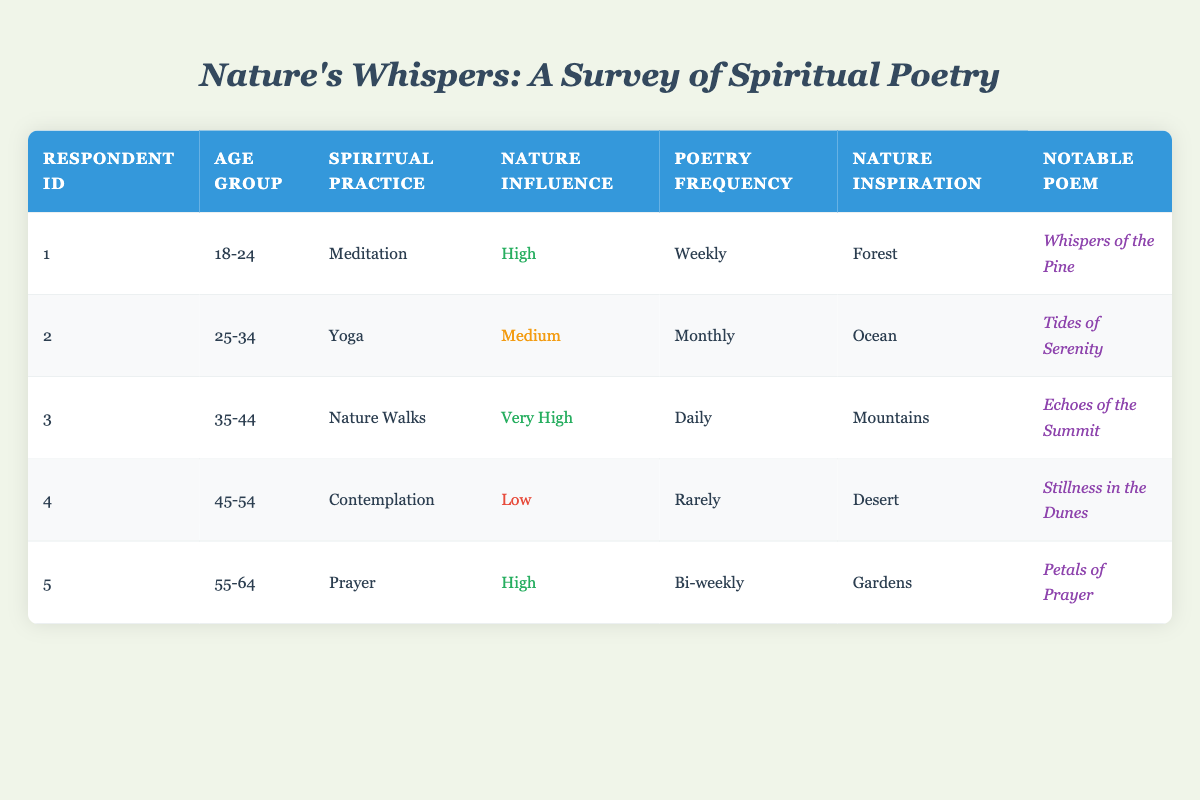What is the favorite nature inspiration of the youngest respondent? The youngest respondent is in the age group 18-24, identified in the first row. Their favorite nature inspiration is listed as "Forest."
Answer: Forest How many respondents engage in poetry creation weekly? Referring to the third row, the respondent listed with a poetry creation frequency of "Daily" and the first row with "Weekly" makes a total of 2 individuals engaging in poetry creation at least weekly.
Answer: 2 Is there any respondent who practices contemplation? Looking through the spiritual practice column, the fourth respondent is engaged in "Contemplation." Hence, the answer is yes.
Answer: Yes What is the average nature influence level among all respondents? To find the average, we need to convert the nature influence levels into a numerical scale: High=3, Medium=2, Low=1, Very High=4. Calculating the average: (3 + 2 + 4 + 1 + 3) / 5 = 2.6, which we can round to the nearest value, affecting our summarizing; this would suggest "Medium" as the average overall level.
Answer: Medium Which age group has the highest poetry creation frequency? By examining the frequency of poetry creation, the respondent in the age group 35-44 (with "Daily") produces poetry most frequently compared to others. Hence, they belong to this group.
Answer: 35-44 What is the notable poem associated with the respondent who practices Yoga? The second respondent practices Yoga, and their notable poem associated with it is "Tides of Serenity," as mentioned in the table.
Answer: Tides of Serenity Count how many respondents have high or very high nature influence levels. The first and third respondents have High and Very High nature influence levels respectively, making a total of 3 individuals in that count.
Answer: 3 Which nature inspiration is favored by respondents that create poetry rarely? The respondent who creates poetry "Rarely," which corresponds to age group 45-54, has their favorite nature inspiration listed as "Desert."
Answer: Desert How does the nature influence level relate to the frequency of poetry creation? Analyzing the influence levels against the frequency: Those with high influence create poetry weekly or daily, while low influence results in rare creation. This correlation shows that greater nature influence corresponds with higher poetry creation frequency.
Answer: Higher influence, more frequency 